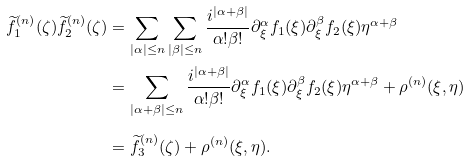Convert formula to latex. <formula><loc_0><loc_0><loc_500><loc_500>\widetilde { f } _ { 1 } ^ { ( n ) } ( \zeta ) \widetilde { f } _ { 2 } ^ { ( n ) } ( \zeta ) & = \sum _ { | \alpha | \leq n } \sum _ { | \beta | \leq n } \frac { i ^ { | \alpha + \beta | } } { \alpha ! \beta ! } \partial _ { \xi } ^ { \alpha } f _ { 1 } ( \xi ) \partial ^ { \beta } _ { \xi } f _ { 2 } ( \xi ) \eta ^ { \alpha + \beta } \\ & = \sum _ { | \alpha + \beta | \leq n } \frac { i ^ { | \alpha + \beta | } } { \alpha ! \beta ! } \partial _ { \xi } ^ { \alpha } f _ { 1 } ( \xi ) \partial ^ { \beta } _ { \xi } f _ { 2 } ( \xi ) \eta ^ { \alpha + \beta } + \rho ^ { ( n ) } ( \xi , \eta ) \\ & = \widetilde { f } _ { 3 } ^ { ( n ) } ( \zeta ) + \rho ^ { ( n ) } ( \xi , \eta ) .</formula> 